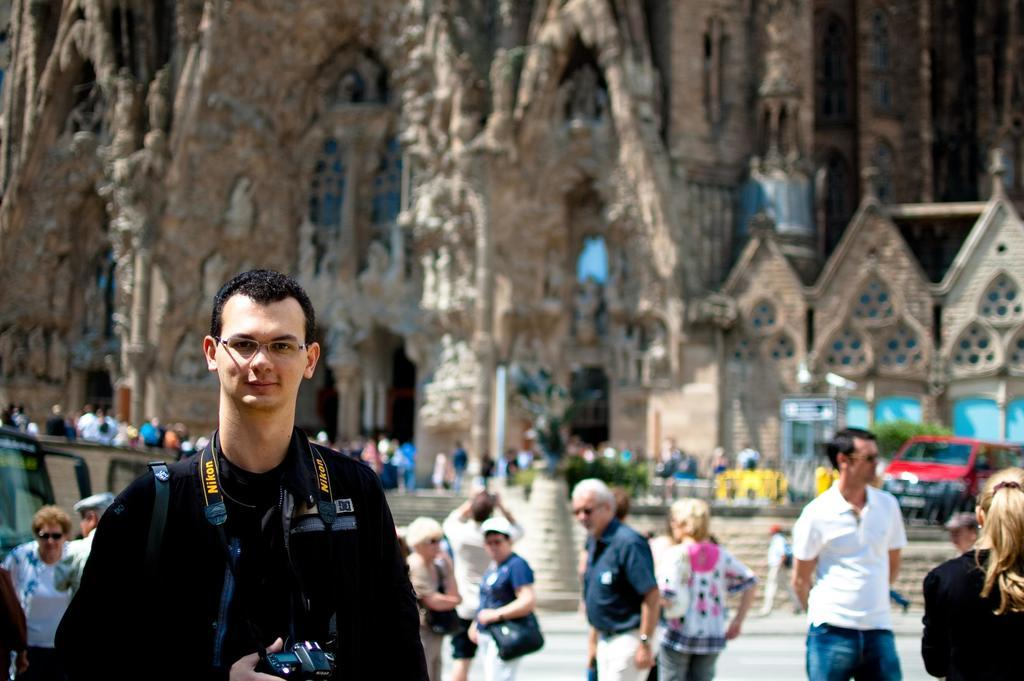Where was the image taken? The image was clicked outside. What can be seen in the foreground of the image? There is a group of people in the foreground. What can be seen in the background of the image? There is a building, stairs, vehicles, and a group of persons in the background. How many groups of people are visible in the image? There are two groups of people visible in the image, one in the foreground and one in the background. What other objects can be seen in the background of the image? There are many other objects visible in the background, but their specific details are not mentioned in the provided facts. What type of eggnog is being served to the group of people in the image? There is no mention of eggnog or any food or drink in the image. --- Facts: 1. There is a person holding a book in the image. 2. The person is sitting on a chair. 3. The chair is made of wood. 4. There is a table next to the chair. 5. The table has a lamp on it. 6. The background of the image is dark. Absurd Topics: dance, ocean, fireworks Conversation: What is the person in the image holding? The person is holding a book in the image. What is the person sitting on? The person is sitting on a chair. What material is the chair made of? The chair is made of wood. What is on the table next to the chair? The table has a lamp on it. What can be seen in the background of the image? The background of the image is dark. Reasoning: Let's think step by step in order to produce the conversation. We start by identifying the main subject in the image, which is the person holding a book. Then, we describe the chair and table that the person is using, as well as the lamp on the table. Finally, we mention the background of the image, which is dark. Each question is designed to elicit a specific detail about the image that is known from the provided facts. Absurd Question/Answer: Can you see any fireworks in the image? There is no mention of fireworks or any similar objects in the image. 